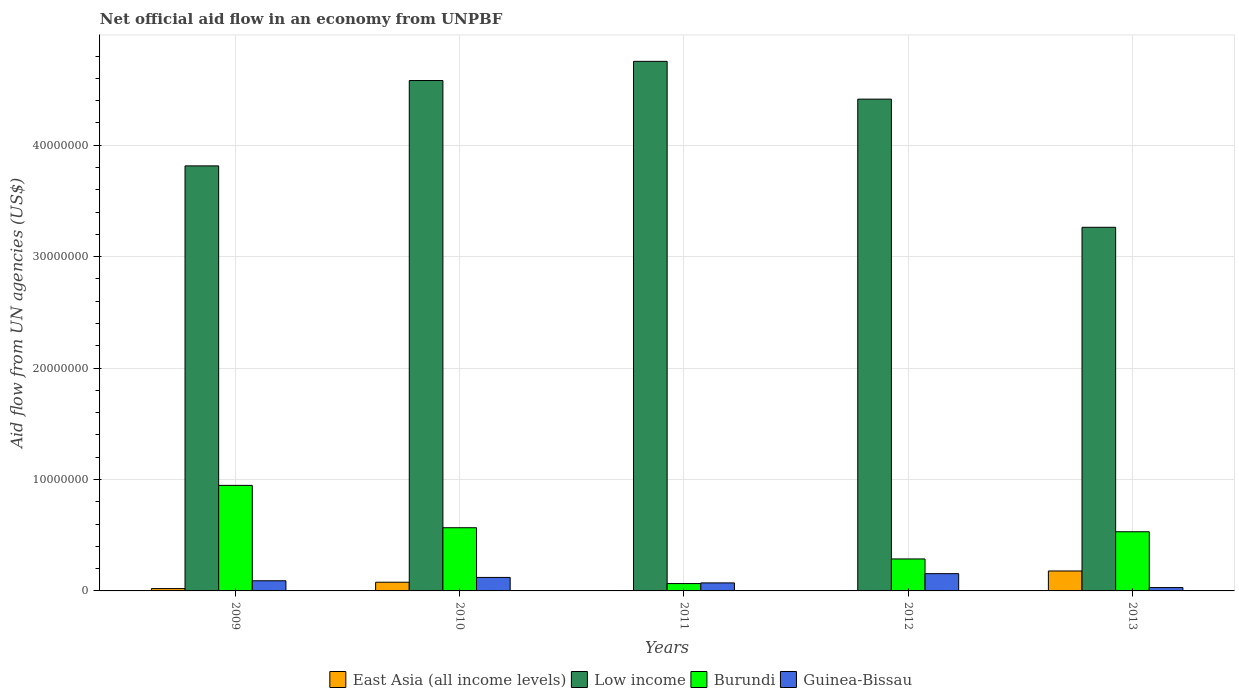How many groups of bars are there?
Make the answer very short. 5. Are the number of bars per tick equal to the number of legend labels?
Give a very brief answer. Yes. Are the number of bars on each tick of the X-axis equal?
Give a very brief answer. Yes. What is the label of the 2nd group of bars from the left?
Your answer should be compact. 2010. What is the net official aid flow in Guinea-Bissau in 2009?
Make the answer very short. 9.10e+05. Across all years, what is the maximum net official aid flow in Guinea-Bissau?
Provide a succinct answer. 1.55e+06. Across all years, what is the minimum net official aid flow in Low income?
Keep it short and to the point. 3.26e+07. In which year was the net official aid flow in East Asia (all income levels) minimum?
Ensure brevity in your answer.  2011. What is the total net official aid flow in East Asia (all income levels) in the graph?
Offer a terse response. 2.81e+06. What is the difference between the net official aid flow in Low income in 2010 and that in 2012?
Your answer should be compact. 1.67e+06. What is the difference between the net official aid flow in Guinea-Bissau in 2011 and the net official aid flow in East Asia (all income levels) in 2012?
Ensure brevity in your answer.  7.00e+05. What is the average net official aid flow in Low income per year?
Your response must be concise. 4.16e+07. In the year 2011, what is the difference between the net official aid flow in Guinea-Bissau and net official aid flow in East Asia (all income levels)?
Keep it short and to the point. 7.10e+05. In how many years, is the net official aid flow in Burundi greater than 42000000 US$?
Give a very brief answer. 0. Is the net official aid flow in Low income in 2009 less than that in 2013?
Your answer should be compact. No. What is the difference between the highest and the second highest net official aid flow in Low income?
Your answer should be compact. 1.72e+06. What is the difference between the highest and the lowest net official aid flow in Low income?
Make the answer very short. 1.49e+07. How many bars are there?
Your answer should be compact. 20. Are all the bars in the graph horizontal?
Provide a succinct answer. No. What is the difference between two consecutive major ticks on the Y-axis?
Ensure brevity in your answer.  1.00e+07. Are the values on the major ticks of Y-axis written in scientific E-notation?
Provide a succinct answer. No. Does the graph contain any zero values?
Give a very brief answer. No. Where does the legend appear in the graph?
Your answer should be compact. Bottom center. How many legend labels are there?
Give a very brief answer. 4. What is the title of the graph?
Make the answer very short. Net official aid flow in an economy from UNPBF. Does "Other small states" appear as one of the legend labels in the graph?
Your answer should be compact. No. What is the label or title of the Y-axis?
Offer a terse response. Aid flow from UN agencies (US$). What is the Aid flow from UN agencies (US$) in Low income in 2009?
Give a very brief answer. 3.81e+07. What is the Aid flow from UN agencies (US$) in Burundi in 2009?
Offer a very short reply. 9.47e+06. What is the Aid flow from UN agencies (US$) in Guinea-Bissau in 2009?
Provide a short and direct response. 9.10e+05. What is the Aid flow from UN agencies (US$) of East Asia (all income levels) in 2010?
Your answer should be very brief. 7.80e+05. What is the Aid flow from UN agencies (US$) in Low income in 2010?
Make the answer very short. 4.58e+07. What is the Aid flow from UN agencies (US$) of Burundi in 2010?
Your answer should be very brief. 5.67e+06. What is the Aid flow from UN agencies (US$) in Guinea-Bissau in 2010?
Make the answer very short. 1.21e+06. What is the Aid flow from UN agencies (US$) of East Asia (all income levels) in 2011?
Provide a succinct answer. 10000. What is the Aid flow from UN agencies (US$) of Low income in 2011?
Your answer should be very brief. 4.75e+07. What is the Aid flow from UN agencies (US$) of Guinea-Bissau in 2011?
Give a very brief answer. 7.20e+05. What is the Aid flow from UN agencies (US$) in Low income in 2012?
Offer a very short reply. 4.41e+07. What is the Aid flow from UN agencies (US$) of Burundi in 2012?
Offer a very short reply. 2.87e+06. What is the Aid flow from UN agencies (US$) in Guinea-Bissau in 2012?
Your answer should be very brief. 1.55e+06. What is the Aid flow from UN agencies (US$) of East Asia (all income levels) in 2013?
Keep it short and to the point. 1.79e+06. What is the Aid flow from UN agencies (US$) in Low income in 2013?
Your answer should be compact. 3.26e+07. What is the Aid flow from UN agencies (US$) in Burundi in 2013?
Your response must be concise. 5.31e+06. Across all years, what is the maximum Aid flow from UN agencies (US$) in East Asia (all income levels)?
Ensure brevity in your answer.  1.79e+06. Across all years, what is the maximum Aid flow from UN agencies (US$) in Low income?
Make the answer very short. 4.75e+07. Across all years, what is the maximum Aid flow from UN agencies (US$) of Burundi?
Your answer should be compact. 9.47e+06. Across all years, what is the maximum Aid flow from UN agencies (US$) in Guinea-Bissau?
Make the answer very short. 1.55e+06. Across all years, what is the minimum Aid flow from UN agencies (US$) in Low income?
Offer a terse response. 3.26e+07. Across all years, what is the minimum Aid flow from UN agencies (US$) of Burundi?
Ensure brevity in your answer.  6.60e+05. Across all years, what is the minimum Aid flow from UN agencies (US$) of Guinea-Bissau?
Keep it short and to the point. 3.00e+05. What is the total Aid flow from UN agencies (US$) of East Asia (all income levels) in the graph?
Your response must be concise. 2.81e+06. What is the total Aid flow from UN agencies (US$) in Low income in the graph?
Your answer should be compact. 2.08e+08. What is the total Aid flow from UN agencies (US$) of Burundi in the graph?
Ensure brevity in your answer.  2.40e+07. What is the total Aid flow from UN agencies (US$) in Guinea-Bissau in the graph?
Ensure brevity in your answer.  4.69e+06. What is the difference between the Aid flow from UN agencies (US$) in East Asia (all income levels) in 2009 and that in 2010?
Provide a succinct answer. -5.70e+05. What is the difference between the Aid flow from UN agencies (US$) in Low income in 2009 and that in 2010?
Provide a succinct answer. -7.66e+06. What is the difference between the Aid flow from UN agencies (US$) in Burundi in 2009 and that in 2010?
Keep it short and to the point. 3.80e+06. What is the difference between the Aid flow from UN agencies (US$) of East Asia (all income levels) in 2009 and that in 2011?
Offer a very short reply. 2.00e+05. What is the difference between the Aid flow from UN agencies (US$) of Low income in 2009 and that in 2011?
Keep it short and to the point. -9.38e+06. What is the difference between the Aid flow from UN agencies (US$) of Burundi in 2009 and that in 2011?
Make the answer very short. 8.81e+06. What is the difference between the Aid flow from UN agencies (US$) in East Asia (all income levels) in 2009 and that in 2012?
Your answer should be very brief. 1.90e+05. What is the difference between the Aid flow from UN agencies (US$) of Low income in 2009 and that in 2012?
Make the answer very short. -5.99e+06. What is the difference between the Aid flow from UN agencies (US$) of Burundi in 2009 and that in 2012?
Provide a short and direct response. 6.60e+06. What is the difference between the Aid flow from UN agencies (US$) of Guinea-Bissau in 2009 and that in 2012?
Offer a very short reply. -6.40e+05. What is the difference between the Aid flow from UN agencies (US$) in East Asia (all income levels) in 2009 and that in 2013?
Provide a short and direct response. -1.58e+06. What is the difference between the Aid flow from UN agencies (US$) in Low income in 2009 and that in 2013?
Your answer should be compact. 5.51e+06. What is the difference between the Aid flow from UN agencies (US$) in Burundi in 2009 and that in 2013?
Your answer should be compact. 4.16e+06. What is the difference between the Aid flow from UN agencies (US$) in East Asia (all income levels) in 2010 and that in 2011?
Ensure brevity in your answer.  7.70e+05. What is the difference between the Aid flow from UN agencies (US$) of Low income in 2010 and that in 2011?
Give a very brief answer. -1.72e+06. What is the difference between the Aid flow from UN agencies (US$) of Burundi in 2010 and that in 2011?
Offer a very short reply. 5.01e+06. What is the difference between the Aid flow from UN agencies (US$) of Guinea-Bissau in 2010 and that in 2011?
Your response must be concise. 4.90e+05. What is the difference between the Aid flow from UN agencies (US$) in East Asia (all income levels) in 2010 and that in 2012?
Provide a short and direct response. 7.60e+05. What is the difference between the Aid flow from UN agencies (US$) in Low income in 2010 and that in 2012?
Your answer should be very brief. 1.67e+06. What is the difference between the Aid flow from UN agencies (US$) of Burundi in 2010 and that in 2012?
Make the answer very short. 2.80e+06. What is the difference between the Aid flow from UN agencies (US$) of East Asia (all income levels) in 2010 and that in 2013?
Provide a succinct answer. -1.01e+06. What is the difference between the Aid flow from UN agencies (US$) of Low income in 2010 and that in 2013?
Provide a succinct answer. 1.32e+07. What is the difference between the Aid flow from UN agencies (US$) in Burundi in 2010 and that in 2013?
Provide a short and direct response. 3.60e+05. What is the difference between the Aid flow from UN agencies (US$) in Guinea-Bissau in 2010 and that in 2013?
Provide a succinct answer. 9.10e+05. What is the difference between the Aid flow from UN agencies (US$) of East Asia (all income levels) in 2011 and that in 2012?
Provide a short and direct response. -10000. What is the difference between the Aid flow from UN agencies (US$) in Low income in 2011 and that in 2012?
Offer a terse response. 3.39e+06. What is the difference between the Aid flow from UN agencies (US$) in Burundi in 2011 and that in 2012?
Your answer should be very brief. -2.21e+06. What is the difference between the Aid flow from UN agencies (US$) in Guinea-Bissau in 2011 and that in 2012?
Provide a succinct answer. -8.30e+05. What is the difference between the Aid flow from UN agencies (US$) of East Asia (all income levels) in 2011 and that in 2013?
Make the answer very short. -1.78e+06. What is the difference between the Aid flow from UN agencies (US$) in Low income in 2011 and that in 2013?
Offer a terse response. 1.49e+07. What is the difference between the Aid flow from UN agencies (US$) of Burundi in 2011 and that in 2013?
Make the answer very short. -4.65e+06. What is the difference between the Aid flow from UN agencies (US$) in Guinea-Bissau in 2011 and that in 2013?
Offer a very short reply. 4.20e+05. What is the difference between the Aid flow from UN agencies (US$) in East Asia (all income levels) in 2012 and that in 2013?
Provide a succinct answer. -1.77e+06. What is the difference between the Aid flow from UN agencies (US$) of Low income in 2012 and that in 2013?
Keep it short and to the point. 1.15e+07. What is the difference between the Aid flow from UN agencies (US$) of Burundi in 2012 and that in 2013?
Provide a short and direct response. -2.44e+06. What is the difference between the Aid flow from UN agencies (US$) of Guinea-Bissau in 2012 and that in 2013?
Your answer should be very brief. 1.25e+06. What is the difference between the Aid flow from UN agencies (US$) in East Asia (all income levels) in 2009 and the Aid flow from UN agencies (US$) in Low income in 2010?
Provide a short and direct response. -4.56e+07. What is the difference between the Aid flow from UN agencies (US$) in East Asia (all income levels) in 2009 and the Aid flow from UN agencies (US$) in Burundi in 2010?
Your response must be concise. -5.46e+06. What is the difference between the Aid flow from UN agencies (US$) in Low income in 2009 and the Aid flow from UN agencies (US$) in Burundi in 2010?
Your response must be concise. 3.25e+07. What is the difference between the Aid flow from UN agencies (US$) of Low income in 2009 and the Aid flow from UN agencies (US$) of Guinea-Bissau in 2010?
Your answer should be compact. 3.69e+07. What is the difference between the Aid flow from UN agencies (US$) of Burundi in 2009 and the Aid flow from UN agencies (US$) of Guinea-Bissau in 2010?
Provide a short and direct response. 8.26e+06. What is the difference between the Aid flow from UN agencies (US$) in East Asia (all income levels) in 2009 and the Aid flow from UN agencies (US$) in Low income in 2011?
Your answer should be very brief. -4.73e+07. What is the difference between the Aid flow from UN agencies (US$) in East Asia (all income levels) in 2009 and the Aid flow from UN agencies (US$) in Burundi in 2011?
Your answer should be very brief. -4.50e+05. What is the difference between the Aid flow from UN agencies (US$) in East Asia (all income levels) in 2009 and the Aid flow from UN agencies (US$) in Guinea-Bissau in 2011?
Your answer should be very brief. -5.10e+05. What is the difference between the Aid flow from UN agencies (US$) in Low income in 2009 and the Aid flow from UN agencies (US$) in Burundi in 2011?
Your response must be concise. 3.75e+07. What is the difference between the Aid flow from UN agencies (US$) of Low income in 2009 and the Aid flow from UN agencies (US$) of Guinea-Bissau in 2011?
Offer a terse response. 3.74e+07. What is the difference between the Aid flow from UN agencies (US$) of Burundi in 2009 and the Aid flow from UN agencies (US$) of Guinea-Bissau in 2011?
Offer a terse response. 8.75e+06. What is the difference between the Aid flow from UN agencies (US$) of East Asia (all income levels) in 2009 and the Aid flow from UN agencies (US$) of Low income in 2012?
Ensure brevity in your answer.  -4.39e+07. What is the difference between the Aid flow from UN agencies (US$) in East Asia (all income levels) in 2009 and the Aid flow from UN agencies (US$) in Burundi in 2012?
Your answer should be very brief. -2.66e+06. What is the difference between the Aid flow from UN agencies (US$) of East Asia (all income levels) in 2009 and the Aid flow from UN agencies (US$) of Guinea-Bissau in 2012?
Offer a very short reply. -1.34e+06. What is the difference between the Aid flow from UN agencies (US$) in Low income in 2009 and the Aid flow from UN agencies (US$) in Burundi in 2012?
Your answer should be very brief. 3.53e+07. What is the difference between the Aid flow from UN agencies (US$) of Low income in 2009 and the Aid flow from UN agencies (US$) of Guinea-Bissau in 2012?
Your answer should be very brief. 3.66e+07. What is the difference between the Aid flow from UN agencies (US$) in Burundi in 2009 and the Aid flow from UN agencies (US$) in Guinea-Bissau in 2012?
Give a very brief answer. 7.92e+06. What is the difference between the Aid flow from UN agencies (US$) in East Asia (all income levels) in 2009 and the Aid flow from UN agencies (US$) in Low income in 2013?
Keep it short and to the point. -3.24e+07. What is the difference between the Aid flow from UN agencies (US$) of East Asia (all income levels) in 2009 and the Aid flow from UN agencies (US$) of Burundi in 2013?
Provide a succinct answer. -5.10e+06. What is the difference between the Aid flow from UN agencies (US$) of East Asia (all income levels) in 2009 and the Aid flow from UN agencies (US$) of Guinea-Bissau in 2013?
Keep it short and to the point. -9.00e+04. What is the difference between the Aid flow from UN agencies (US$) in Low income in 2009 and the Aid flow from UN agencies (US$) in Burundi in 2013?
Offer a terse response. 3.28e+07. What is the difference between the Aid flow from UN agencies (US$) in Low income in 2009 and the Aid flow from UN agencies (US$) in Guinea-Bissau in 2013?
Give a very brief answer. 3.78e+07. What is the difference between the Aid flow from UN agencies (US$) in Burundi in 2009 and the Aid flow from UN agencies (US$) in Guinea-Bissau in 2013?
Offer a terse response. 9.17e+06. What is the difference between the Aid flow from UN agencies (US$) in East Asia (all income levels) in 2010 and the Aid flow from UN agencies (US$) in Low income in 2011?
Provide a short and direct response. -4.67e+07. What is the difference between the Aid flow from UN agencies (US$) of East Asia (all income levels) in 2010 and the Aid flow from UN agencies (US$) of Guinea-Bissau in 2011?
Your answer should be very brief. 6.00e+04. What is the difference between the Aid flow from UN agencies (US$) of Low income in 2010 and the Aid flow from UN agencies (US$) of Burundi in 2011?
Keep it short and to the point. 4.51e+07. What is the difference between the Aid flow from UN agencies (US$) of Low income in 2010 and the Aid flow from UN agencies (US$) of Guinea-Bissau in 2011?
Offer a terse response. 4.51e+07. What is the difference between the Aid flow from UN agencies (US$) of Burundi in 2010 and the Aid flow from UN agencies (US$) of Guinea-Bissau in 2011?
Provide a short and direct response. 4.95e+06. What is the difference between the Aid flow from UN agencies (US$) in East Asia (all income levels) in 2010 and the Aid flow from UN agencies (US$) in Low income in 2012?
Your response must be concise. -4.34e+07. What is the difference between the Aid flow from UN agencies (US$) in East Asia (all income levels) in 2010 and the Aid flow from UN agencies (US$) in Burundi in 2012?
Give a very brief answer. -2.09e+06. What is the difference between the Aid flow from UN agencies (US$) in East Asia (all income levels) in 2010 and the Aid flow from UN agencies (US$) in Guinea-Bissau in 2012?
Give a very brief answer. -7.70e+05. What is the difference between the Aid flow from UN agencies (US$) of Low income in 2010 and the Aid flow from UN agencies (US$) of Burundi in 2012?
Offer a very short reply. 4.29e+07. What is the difference between the Aid flow from UN agencies (US$) of Low income in 2010 and the Aid flow from UN agencies (US$) of Guinea-Bissau in 2012?
Ensure brevity in your answer.  4.42e+07. What is the difference between the Aid flow from UN agencies (US$) of Burundi in 2010 and the Aid flow from UN agencies (US$) of Guinea-Bissau in 2012?
Provide a succinct answer. 4.12e+06. What is the difference between the Aid flow from UN agencies (US$) of East Asia (all income levels) in 2010 and the Aid flow from UN agencies (US$) of Low income in 2013?
Provide a short and direct response. -3.18e+07. What is the difference between the Aid flow from UN agencies (US$) in East Asia (all income levels) in 2010 and the Aid flow from UN agencies (US$) in Burundi in 2013?
Give a very brief answer. -4.53e+06. What is the difference between the Aid flow from UN agencies (US$) in Low income in 2010 and the Aid flow from UN agencies (US$) in Burundi in 2013?
Offer a very short reply. 4.05e+07. What is the difference between the Aid flow from UN agencies (US$) in Low income in 2010 and the Aid flow from UN agencies (US$) in Guinea-Bissau in 2013?
Keep it short and to the point. 4.55e+07. What is the difference between the Aid flow from UN agencies (US$) in Burundi in 2010 and the Aid flow from UN agencies (US$) in Guinea-Bissau in 2013?
Offer a very short reply. 5.37e+06. What is the difference between the Aid flow from UN agencies (US$) of East Asia (all income levels) in 2011 and the Aid flow from UN agencies (US$) of Low income in 2012?
Ensure brevity in your answer.  -4.41e+07. What is the difference between the Aid flow from UN agencies (US$) in East Asia (all income levels) in 2011 and the Aid flow from UN agencies (US$) in Burundi in 2012?
Give a very brief answer. -2.86e+06. What is the difference between the Aid flow from UN agencies (US$) of East Asia (all income levels) in 2011 and the Aid flow from UN agencies (US$) of Guinea-Bissau in 2012?
Your response must be concise. -1.54e+06. What is the difference between the Aid flow from UN agencies (US$) in Low income in 2011 and the Aid flow from UN agencies (US$) in Burundi in 2012?
Give a very brief answer. 4.46e+07. What is the difference between the Aid flow from UN agencies (US$) of Low income in 2011 and the Aid flow from UN agencies (US$) of Guinea-Bissau in 2012?
Provide a short and direct response. 4.60e+07. What is the difference between the Aid flow from UN agencies (US$) in Burundi in 2011 and the Aid flow from UN agencies (US$) in Guinea-Bissau in 2012?
Keep it short and to the point. -8.90e+05. What is the difference between the Aid flow from UN agencies (US$) of East Asia (all income levels) in 2011 and the Aid flow from UN agencies (US$) of Low income in 2013?
Provide a succinct answer. -3.26e+07. What is the difference between the Aid flow from UN agencies (US$) of East Asia (all income levels) in 2011 and the Aid flow from UN agencies (US$) of Burundi in 2013?
Provide a succinct answer. -5.30e+06. What is the difference between the Aid flow from UN agencies (US$) of Low income in 2011 and the Aid flow from UN agencies (US$) of Burundi in 2013?
Offer a very short reply. 4.22e+07. What is the difference between the Aid flow from UN agencies (US$) in Low income in 2011 and the Aid flow from UN agencies (US$) in Guinea-Bissau in 2013?
Offer a terse response. 4.72e+07. What is the difference between the Aid flow from UN agencies (US$) in East Asia (all income levels) in 2012 and the Aid flow from UN agencies (US$) in Low income in 2013?
Provide a succinct answer. -3.26e+07. What is the difference between the Aid flow from UN agencies (US$) of East Asia (all income levels) in 2012 and the Aid flow from UN agencies (US$) of Burundi in 2013?
Provide a short and direct response. -5.29e+06. What is the difference between the Aid flow from UN agencies (US$) in East Asia (all income levels) in 2012 and the Aid flow from UN agencies (US$) in Guinea-Bissau in 2013?
Make the answer very short. -2.80e+05. What is the difference between the Aid flow from UN agencies (US$) of Low income in 2012 and the Aid flow from UN agencies (US$) of Burundi in 2013?
Your answer should be compact. 3.88e+07. What is the difference between the Aid flow from UN agencies (US$) of Low income in 2012 and the Aid flow from UN agencies (US$) of Guinea-Bissau in 2013?
Make the answer very short. 4.38e+07. What is the difference between the Aid flow from UN agencies (US$) of Burundi in 2012 and the Aid flow from UN agencies (US$) of Guinea-Bissau in 2013?
Give a very brief answer. 2.57e+06. What is the average Aid flow from UN agencies (US$) of East Asia (all income levels) per year?
Give a very brief answer. 5.62e+05. What is the average Aid flow from UN agencies (US$) of Low income per year?
Your answer should be compact. 4.16e+07. What is the average Aid flow from UN agencies (US$) in Burundi per year?
Keep it short and to the point. 4.80e+06. What is the average Aid flow from UN agencies (US$) of Guinea-Bissau per year?
Keep it short and to the point. 9.38e+05. In the year 2009, what is the difference between the Aid flow from UN agencies (US$) of East Asia (all income levels) and Aid flow from UN agencies (US$) of Low income?
Offer a very short reply. -3.79e+07. In the year 2009, what is the difference between the Aid flow from UN agencies (US$) in East Asia (all income levels) and Aid flow from UN agencies (US$) in Burundi?
Your answer should be very brief. -9.26e+06. In the year 2009, what is the difference between the Aid flow from UN agencies (US$) of East Asia (all income levels) and Aid flow from UN agencies (US$) of Guinea-Bissau?
Make the answer very short. -7.00e+05. In the year 2009, what is the difference between the Aid flow from UN agencies (US$) in Low income and Aid flow from UN agencies (US$) in Burundi?
Make the answer very short. 2.87e+07. In the year 2009, what is the difference between the Aid flow from UN agencies (US$) of Low income and Aid flow from UN agencies (US$) of Guinea-Bissau?
Give a very brief answer. 3.72e+07. In the year 2009, what is the difference between the Aid flow from UN agencies (US$) in Burundi and Aid flow from UN agencies (US$) in Guinea-Bissau?
Provide a succinct answer. 8.56e+06. In the year 2010, what is the difference between the Aid flow from UN agencies (US$) in East Asia (all income levels) and Aid flow from UN agencies (US$) in Low income?
Give a very brief answer. -4.50e+07. In the year 2010, what is the difference between the Aid flow from UN agencies (US$) of East Asia (all income levels) and Aid flow from UN agencies (US$) of Burundi?
Provide a succinct answer. -4.89e+06. In the year 2010, what is the difference between the Aid flow from UN agencies (US$) in East Asia (all income levels) and Aid flow from UN agencies (US$) in Guinea-Bissau?
Provide a succinct answer. -4.30e+05. In the year 2010, what is the difference between the Aid flow from UN agencies (US$) in Low income and Aid flow from UN agencies (US$) in Burundi?
Ensure brevity in your answer.  4.01e+07. In the year 2010, what is the difference between the Aid flow from UN agencies (US$) in Low income and Aid flow from UN agencies (US$) in Guinea-Bissau?
Your response must be concise. 4.46e+07. In the year 2010, what is the difference between the Aid flow from UN agencies (US$) in Burundi and Aid flow from UN agencies (US$) in Guinea-Bissau?
Your response must be concise. 4.46e+06. In the year 2011, what is the difference between the Aid flow from UN agencies (US$) of East Asia (all income levels) and Aid flow from UN agencies (US$) of Low income?
Your answer should be compact. -4.75e+07. In the year 2011, what is the difference between the Aid flow from UN agencies (US$) of East Asia (all income levels) and Aid flow from UN agencies (US$) of Burundi?
Offer a very short reply. -6.50e+05. In the year 2011, what is the difference between the Aid flow from UN agencies (US$) in East Asia (all income levels) and Aid flow from UN agencies (US$) in Guinea-Bissau?
Offer a very short reply. -7.10e+05. In the year 2011, what is the difference between the Aid flow from UN agencies (US$) of Low income and Aid flow from UN agencies (US$) of Burundi?
Provide a succinct answer. 4.69e+07. In the year 2011, what is the difference between the Aid flow from UN agencies (US$) in Low income and Aid flow from UN agencies (US$) in Guinea-Bissau?
Give a very brief answer. 4.68e+07. In the year 2012, what is the difference between the Aid flow from UN agencies (US$) of East Asia (all income levels) and Aid flow from UN agencies (US$) of Low income?
Your response must be concise. -4.41e+07. In the year 2012, what is the difference between the Aid flow from UN agencies (US$) in East Asia (all income levels) and Aid flow from UN agencies (US$) in Burundi?
Provide a succinct answer. -2.85e+06. In the year 2012, what is the difference between the Aid flow from UN agencies (US$) of East Asia (all income levels) and Aid flow from UN agencies (US$) of Guinea-Bissau?
Provide a succinct answer. -1.53e+06. In the year 2012, what is the difference between the Aid flow from UN agencies (US$) of Low income and Aid flow from UN agencies (US$) of Burundi?
Provide a succinct answer. 4.13e+07. In the year 2012, what is the difference between the Aid flow from UN agencies (US$) in Low income and Aid flow from UN agencies (US$) in Guinea-Bissau?
Give a very brief answer. 4.26e+07. In the year 2012, what is the difference between the Aid flow from UN agencies (US$) in Burundi and Aid flow from UN agencies (US$) in Guinea-Bissau?
Provide a succinct answer. 1.32e+06. In the year 2013, what is the difference between the Aid flow from UN agencies (US$) of East Asia (all income levels) and Aid flow from UN agencies (US$) of Low income?
Your response must be concise. -3.08e+07. In the year 2013, what is the difference between the Aid flow from UN agencies (US$) in East Asia (all income levels) and Aid flow from UN agencies (US$) in Burundi?
Provide a succinct answer. -3.52e+06. In the year 2013, what is the difference between the Aid flow from UN agencies (US$) of East Asia (all income levels) and Aid flow from UN agencies (US$) of Guinea-Bissau?
Offer a terse response. 1.49e+06. In the year 2013, what is the difference between the Aid flow from UN agencies (US$) of Low income and Aid flow from UN agencies (US$) of Burundi?
Provide a short and direct response. 2.73e+07. In the year 2013, what is the difference between the Aid flow from UN agencies (US$) in Low income and Aid flow from UN agencies (US$) in Guinea-Bissau?
Provide a short and direct response. 3.23e+07. In the year 2013, what is the difference between the Aid flow from UN agencies (US$) of Burundi and Aid flow from UN agencies (US$) of Guinea-Bissau?
Provide a short and direct response. 5.01e+06. What is the ratio of the Aid flow from UN agencies (US$) of East Asia (all income levels) in 2009 to that in 2010?
Your answer should be very brief. 0.27. What is the ratio of the Aid flow from UN agencies (US$) of Low income in 2009 to that in 2010?
Provide a succinct answer. 0.83. What is the ratio of the Aid flow from UN agencies (US$) of Burundi in 2009 to that in 2010?
Your response must be concise. 1.67. What is the ratio of the Aid flow from UN agencies (US$) in Guinea-Bissau in 2009 to that in 2010?
Make the answer very short. 0.75. What is the ratio of the Aid flow from UN agencies (US$) in Low income in 2009 to that in 2011?
Provide a short and direct response. 0.8. What is the ratio of the Aid flow from UN agencies (US$) in Burundi in 2009 to that in 2011?
Offer a terse response. 14.35. What is the ratio of the Aid flow from UN agencies (US$) of Guinea-Bissau in 2009 to that in 2011?
Ensure brevity in your answer.  1.26. What is the ratio of the Aid flow from UN agencies (US$) of East Asia (all income levels) in 2009 to that in 2012?
Ensure brevity in your answer.  10.5. What is the ratio of the Aid flow from UN agencies (US$) in Low income in 2009 to that in 2012?
Your response must be concise. 0.86. What is the ratio of the Aid flow from UN agencies (US$) of Burundi in 2009 to that in 2012?
Offer a terse response. 3.3. What is the ratio of the Aid flow from UN agencies (US$) in Guinea-Bissau in 2009 to that in 2012?
Provide a succinct answer. 0.59. What is the ratio of the Aid flow from UN agencies (US$) of East Asia (all income levels) in 2009 to that in 2013?
Give a very brief answer. 0.12. What is the ratio of the Aid flow from UN agencies (US$) in Low income in 2009 to that in 2013?
Make the answer very short. 1.17. What is the ratio of the Aid flow from UN agencies (US$) of Burundi in 2009 to that in 2013?
Provide a short and direct response. 1.78. What is the ratio of the Aid flow from UN agencies (US$) in Guinea-Bissau in 2009 to that in 2013?
Ensure brevity in your answer.  3.03. What is the ratio of the Aid flow from UN agencies (US$) of Low income in 2010 to that in 2011?
Your answer should be very brief. 0.96. What is the ratio of the Aid flow from UN agencies (US$) in Burundi in 2010 to that in 2011?
Provide a succinct answer. 8.59. What is the ratio of the Aid flow from UN agencies (US$) in Guinea-Bissau in 2010 to that in 2011?
Offer a very short reply. 1.68. What is the ratio of the Aid flow from UN agencies (US$) of East Asia (all income levels) in 2010 to that in 2012?
Keep it short and to the point. 39. What is the ratio of the Aid flow from UN agencies (US$) of Low income in 2010 to that in 2012?
Ensure brevity in your answer.  1.04. What is the ratio of the Aid flow from UN agencies (US$) of Burundi in 2010 to that in 2012?
Offer a very short reply. 1.98. What is the ratio of the Aid flow from UN agencies (US$) in Guinea-Bissau in 2010 to that in 2012?
Your response must be concise. 0.78. What is the ratio of the Aid flow from UN agencies (US$) of East Asia (all income levels) in 2010 to that in 2013?
Provide a succinct answer. 0.44. What is the ratio of the Aid flow from UN agencies (US$) of Low income in 2010 to that in 2013?
Provide a short and direct response. 1.4. What is the ratio of the Aid flow from UN agencies (US$) of Burundi in 2010 to that in 2013?
Your answer should be very brief. 1.07. What is the ratio of the Aid flow from UN agencies (US$) of Guinea-Bissau in 2010 to that in 2013?
Give a very brief answer. 4.03. What is the ratio of the Aid flow from UN agencies (US$) of East Asia (all income levels) in 2011 to that in 2012?
Provide a succinct answer. 0.5. What is the ratio of the Aid flow from UN agencies (US$) in Low income in 2011 to that in 2012?
Your response must be concise. 1.08. What is the ratio of the Aid flow from UN agencies (US$) of Burundi in 2011 to that in 2012?
Keep it short and to the point. 0.23. What is the ratio of the Aid flow from UN agencies (US$) of Guinea-Bissau in 2011 to that in 2012?
Give a very brief answer. 0.46. What is the ratio of the Aid flow from UN agencies (US$) of East Asia (all income levels) in 2011 to that in 2013?
Your response must be concise. 0.01. What is the ratio of the Aid flow from UN agencies (US$) in Low income in 2011 to that in 2013?
Your response must be concise. 1.46. What is the ratio of the Aid flow from UN agencies (US$) of Burundi in 2011 to that in 2013?
Offer a very short reply. 0.12. What is the ratio of the Aid flow from UN agencies (US$) in Guinea-Bissau in 2011 to that in 2013?
Ensure brevity in your answer.  2.4. What is the ratio of the Aid flow from UN agencies (US$) of East Asia (all income levels) in 2012 to that in 2013?
Give a very brief answer. 0.01. What is the ratio of the Aid flow from UN agencies (US$) of Low income in 2012 to that in 2013?
Ensure brevity in your answer.  1.35. What is the ratio of the Aid flow from UN agencies (US$) in Burundi in 2012 to that in 2013?
Give a very brief answer. 0.54. What is the ratio of the Aid flow from UN agencies (US$) in Guinea-Bissau in 2012 to that in 2013?
Make the answer very short. 5.17. What is the difference between the highest and the second highest Aid flow from UN agencies (US$) of East Asia (all income levels)?
Your response must be concise. 1.01e+06. What is the difference between the highest and the second highest Aid flow from UN agencies (US$) in Low income?
Your response must be concise. 1.72e+06. What is the difference between the highest and the second highest Aid flow from UN agencies (US$) of Burundi?
Offer a terse response. 3.80e+06. What is the difference between the highest and the second highest Aid flow from UN agencies (US$) of Guinea-Bissau?
Provide a succinct answer. 3.40e+05. What is the difference between the highest and the lowest Aid flow from UN agencies (US$) of East Asia (all income levels)?
Make the answer very short. 1.78e+06. What is the difference between the highest and the lowest Aid flow from UN agencies (US$) of Low income?
Your answer should be very brief. 1.49e+07. What is the difference between the highest and the lowest Aid flow from UN agencies (US$) in Burundi?
Your answer should be compact. 8.81e+06. What is the difference between the highest and the lowest Aid flow from UN agencies (US$) of Guinea-Bissau?
Offer a terse response. 1.25e+06. 